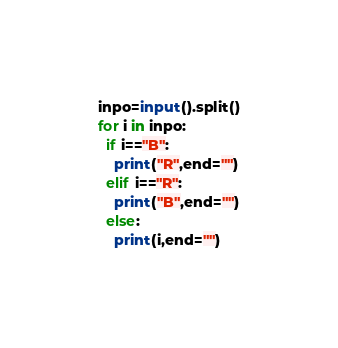<code> <loc_0><loc_0><loc_500><loc_500><_Python_>inpo=input().split()
for i in inpo:
  if i=="B":
    print("R",end="")
  elif i=="R":
    print("B",end="")
  else:
    print(i,end="")</code> 